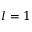<formula> <loc_0><loc_0><loc_500><loc_500>l = 1</formula> 